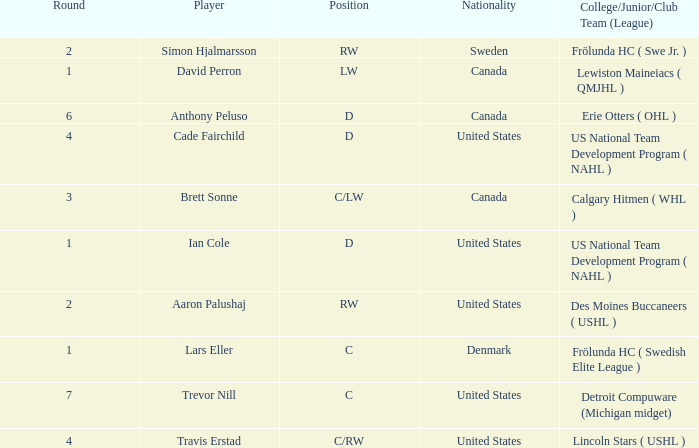What is the position of the player from round 2 from Sweden? RW. Could you parse the entire table? {'header': ['Round', 'Player', 'Position', 'Nationality', 'College/Junior/Club Team (League)'], 'rows': [['2', 'Simon Hjalmarsson', 'RW', 'Sweden', 'Frölunda HC ( Swe Jr. )'], ['1', 'David Perron', 'LW', 'Canada', 'Lewiston Maineiacs ( QMJHL )'], ['6', 'Anthony Peluso', 'D', 'Canada', 'Erie Otters ( OHL )'], ['4', 'Cade Fairchild', 'D', 'United States', 'US National Team Development Program ( NAHL )'], ['3', 'Brett Sonne', 'C/LW', 'Canada', 'Calgary Hitmen ( WHL )'], ['1', 'Ian Cole', 'D', 'United States', 'US National Team Development Program ( NAHL )'], ['2', 'Aaron Palushaj', 'RW', 'United States', 'Des Moines Buccaneers ( USHL )'], ['1', 'Lars Eller', 'C', 'Denmark', 'Frölunda HC ( Swedish Elite League )'], ['7', 'Trevor Nill', 'C', 'United States', 'Detroit Compuware (Michigan midget)'], ['4', 'Travis Erstad', 'C/RW', 'United States', 'Lincoln Stars ( USHL )']]} 